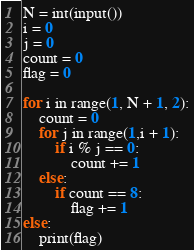Convert code to text. <code><loc_0><loc_0><loc_500><loc_500><_Python_>N = int(input())
i = 0
j = 0
count = 0
flag = 0

for i in range(1, N + 1, 2):
    count = 0
    for j in range(1,i + 1):
        if i % j == 0:
            count += 1
    else:
        if count == 8:
            flag += 1
else:
    print(flag)
</code> 